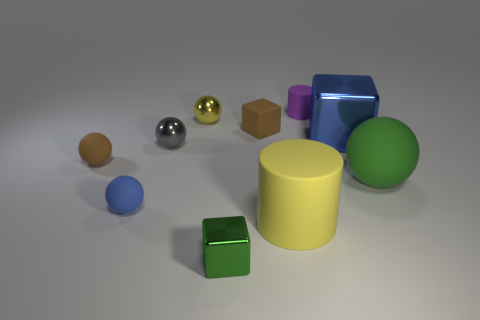How many blue things are either tiny cubes or cubes?
Make the answer very short. 1. Is the color of the large matte thing in front of the large green ball the same as the rubber block?
Provide a succinct answer. No. Do the yellow sphere and the small purple thing have the same material?
Ensure brevity in your answer.  No. Is the number of small purple rubber things behind the tiny purple object the same as the number of large green balls in front of the small green cube?
Keep it short and to the point. Yes. What is the material of the small brown object that is the same shape as the big green thing?
Your answer should be compact. Rubber. There is a blue object to the right of the metal cube in front of the green object behind the small blue rubber ball; what shape is it?
Keep it short and to the point. Cube. Are there more blue objects behind the yellow matte thing than large green spheres?
Provide a succinct answer. Yes. Does the green matte thing that is behind the green shiny block have the same shape as the purple thing?
Offer a very short reply. No. There is a brown thing that is in front of the small matte block; what is its material?
Keep it short and to the point. Rubber. What number of big red matte things are the same shape as the tiny green object?
Offer a terse response. 0. 